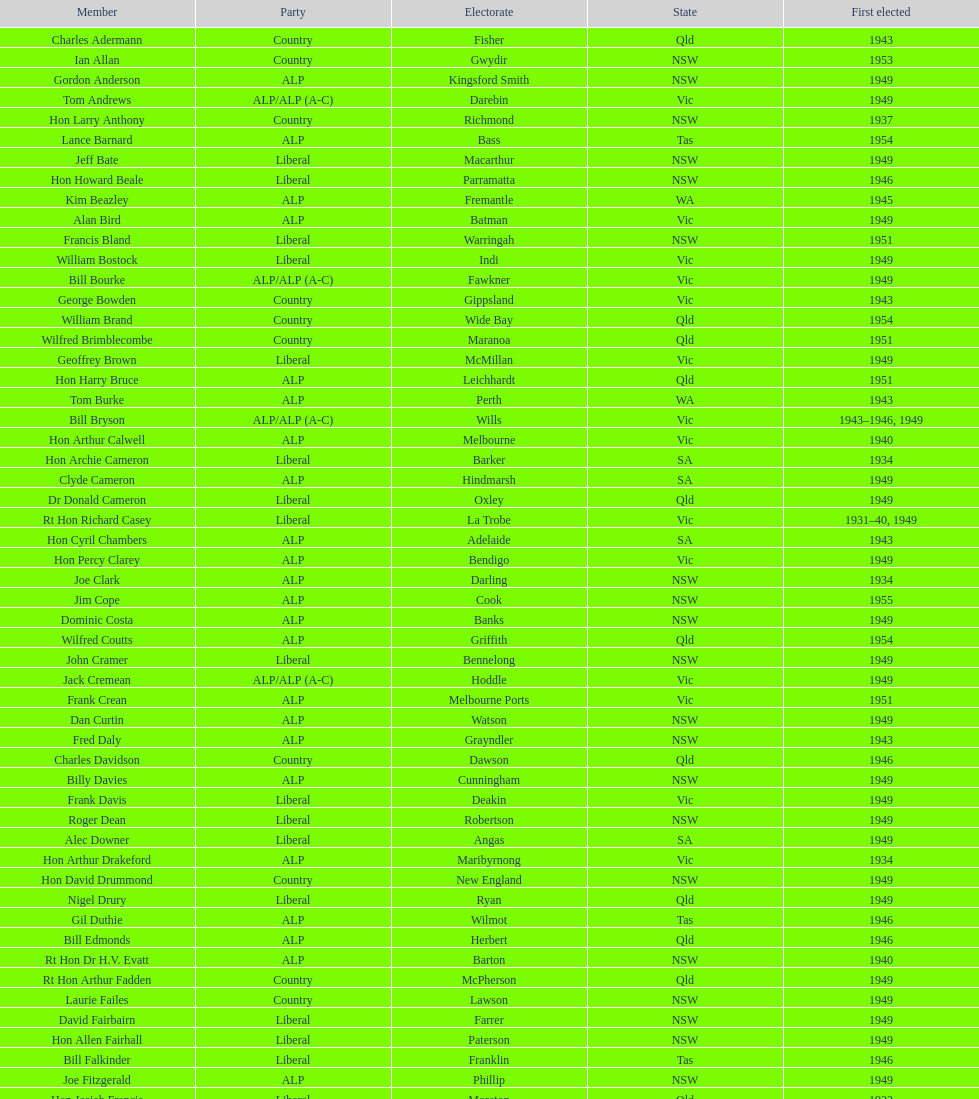When was joe clark first elected? 1934. 